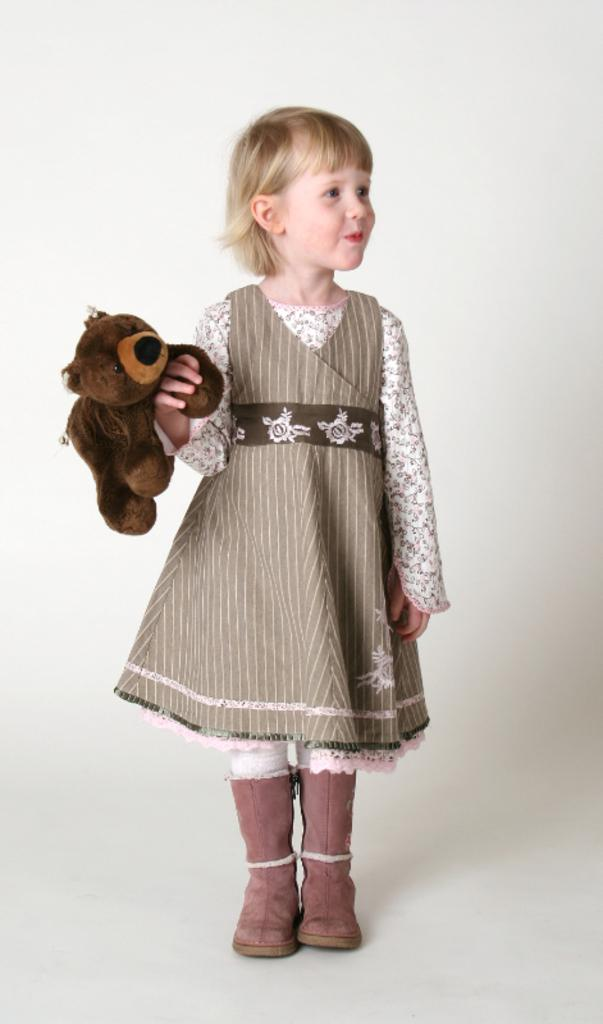Who is the main subject in the image? There is a girl in the image. What is the girl wearing on her feet? The girl is wearing shoes. What object is the girl holding in the image? The girl is holding a teddy bear. What expression does the girl have on her face? The girl is smiling. What is the girl standing on in the image? The girl is standing on a surface. What type of snow can be seen falling in the image? There is no snow present in the image. How many robins are perched on the girl's shoulder in the image? There are no robins present in the image. 